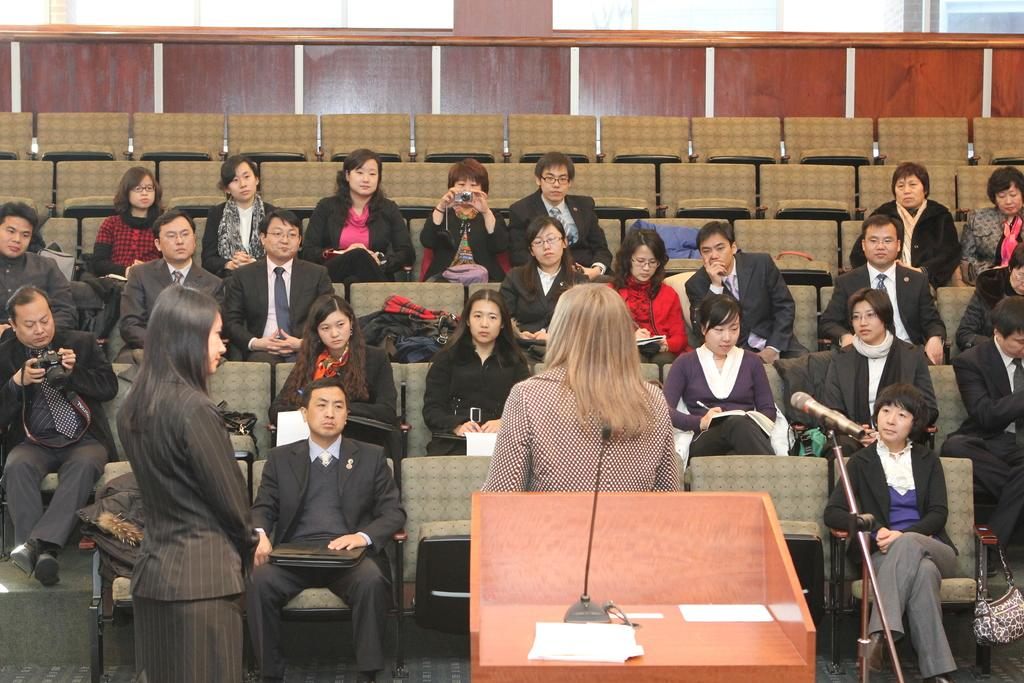How many ladies are in the image? There are two ladies in the image. What are the ladies doing in the image? The two ladies are standing. Can you describe the group of people in the image? The group of people in the image consists of people sitting in chairs. What type of ghost can be seen in the image? There is no ghost present in the image. What feeling does the image evoke in the viewer? The image itself does not evoke a specific feeling, as feelings are subjective and vary from person to person. What thing is being used by the people sitting in chairs? The provided facts do not mention any specific thing being used by the people sitting in chairs. 